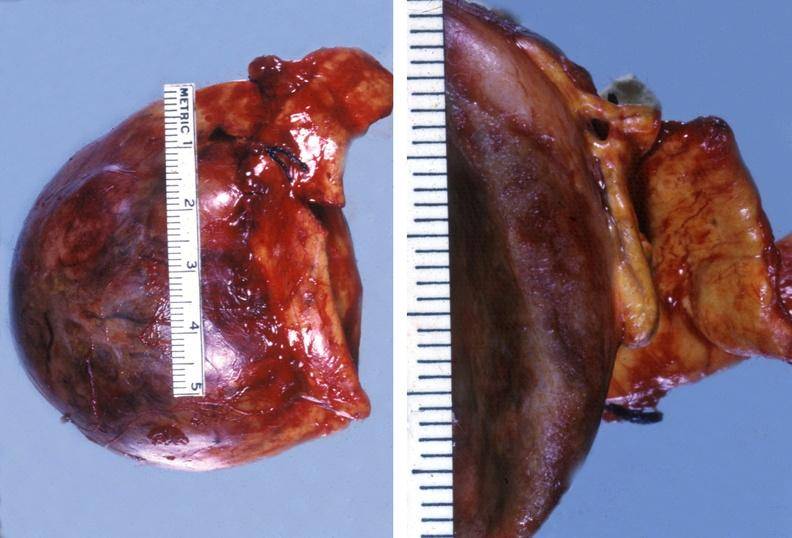s angiogram present?
Answer the question using a single word or phrase. No 